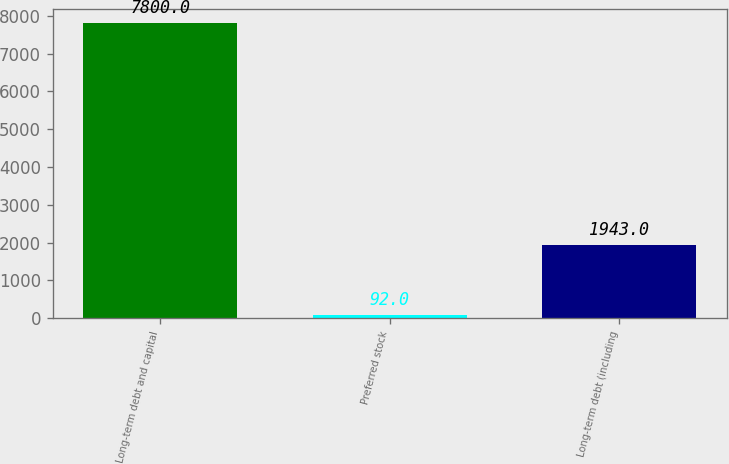Convert chart to OTSL. <chart><loc_0><loc_0><loc_500><loc_500><bar_chart><fcel>Long-term debt and capital<fcel>Preferred stock<fcel>Long-term debt (including<nl><fcel>7800<fcel>92<fcel>1943<nl></chart> 